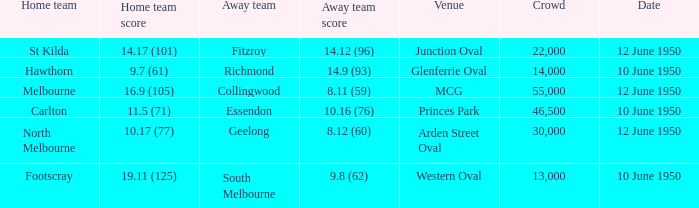What was the gathering when melbourne was the home team? 55000.0. 